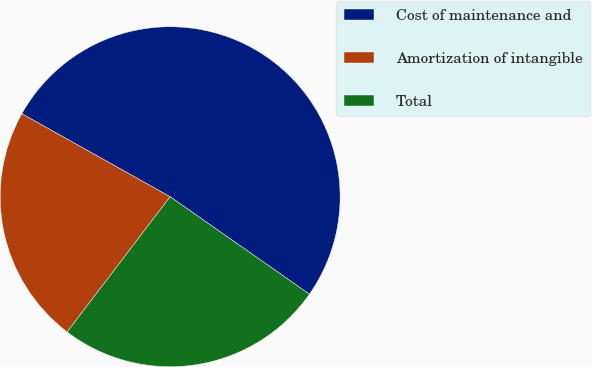Convert chart to OTSL. <chart><loc_0><loc_0><loc_500><loc_500><pie_chart><fcel>Cost of maintenance and<fcel>Amortization of intangible<fcel>Total<nl><fcel>51.59%<fcel>22.76%<fcel>25.64%<nl></chart> 